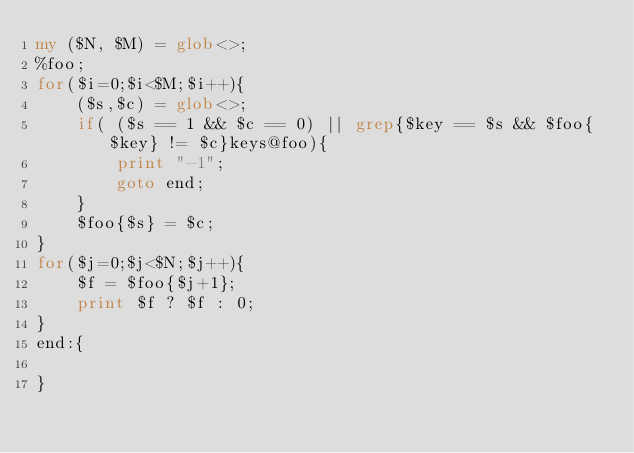Convert code to text. <code><loc_0><loc_0><loc_500><loc_500><_Perl_>my ($N, $M) = glob<>;
%foo;
for($i=0;$i<$M;$i++){
    ($s,$c) = glob<>;
    if( ($s == 1 && $c == 0) || grep{$key == $s && $foo{$key} != $c}keys@foo){
        print "-1";
        goto end;
    }
    $foo{$s} = $c;
}
for($j=0;$j<$N;$j++){
    $f = $foo{$j+1};
    print $f ? $f : 0;
}
end:{

}</code> 